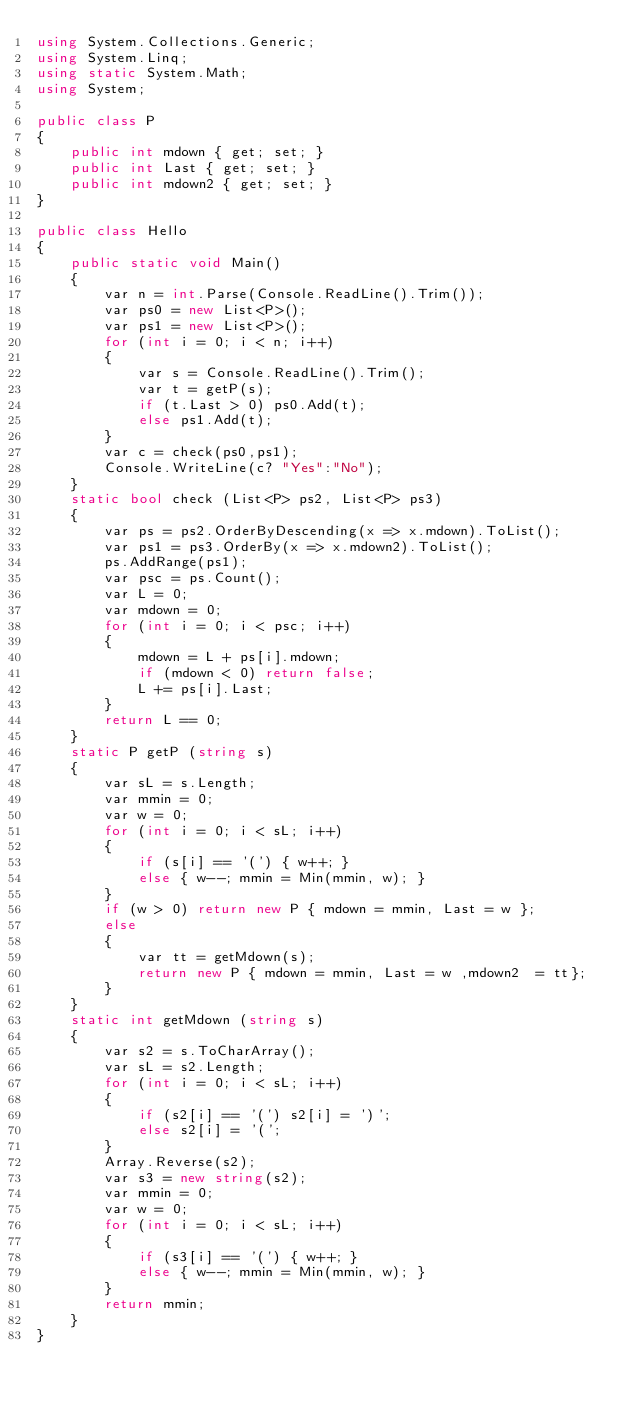Convert code to text. <code><loc_0><loc_0><loc_500><loc_500><_C#_>using System.Collections.Generic;
using System.Linq;
using static System.Math;
using System;

public class P
{
    public int mdown { get; set; }
    public int Last { get; set; }
    public int mdown2 { get; set; }
}

public class Hello
{
    public static void Main()
    {
        var n = int.Parse(Console.ReadLine().Trim());
        var ps0 = new List<P>();
        var ps1 = new List<P>();
        for (int i = 0; i < n; i++)
        {
            var s = Console.ReadLine().Trim();
            var t = getP(s);
            if (t.Last > 0) ps0.Add(t);
            else ps1.Add(t);
        }
        var c = check(ps0,ps1);
        Console.WriteLine(c? "Yes":"No");
    }
    static bool check (List<P> ps2, List<P> ps3)
    {
        var ps = ps2.OrderByDescending(x => x.mdown).ToList();
        var ps1 = ps3.OrderBy(x => x.mdown2).ToList();
        ps.AddRange(ps1);
        var psc = ps.Count();
        var L = 0;
        var mdown = 0;
        for (int i = 0; i < psc; i++)
        {
            mdown = L + ps[i].mdown;
            if (mdown < 0) return false;
            L += ps[i].Last;
        }
        return L == 0;
    }
    static P getP (string s)
    {
        var sL = s.Length;
        var mmin = 0;
        var w = 0;
        for (int i = 0; i < sL; i++)
        {
            if (s[i] == '(') { w++; }
            else { w--; mmin = Min(mmin, w); }
        }
        if (w > 0) return new P { mdown = mmin, Last = w };
        else
        {
            var tt = getMdown(s);
            return new P { mdown = mmin, Last = w ,mdown2  = tt};
        }
    }
    static int getMdown (string s)
    {
        var s2 = s.ToCharArray();
        var sL = s2.Length;
        for (int i = 0; i < sL; i++)
        {
            if (s2[i] == '(') s2[i] = ')';
            else s2[i] = '(';
        }
        Array.Reverse(s2);
        var s3 = new string(s2);
        var mmin = 0;
        var w = 0;
        for (int i = 0; i < sL; i++)
        {
            if (s3[i] == '(') { w++; }
            else { w--; mmin = Min(mmin, w); }
        }
        return mmin;
    }
}

</code> 